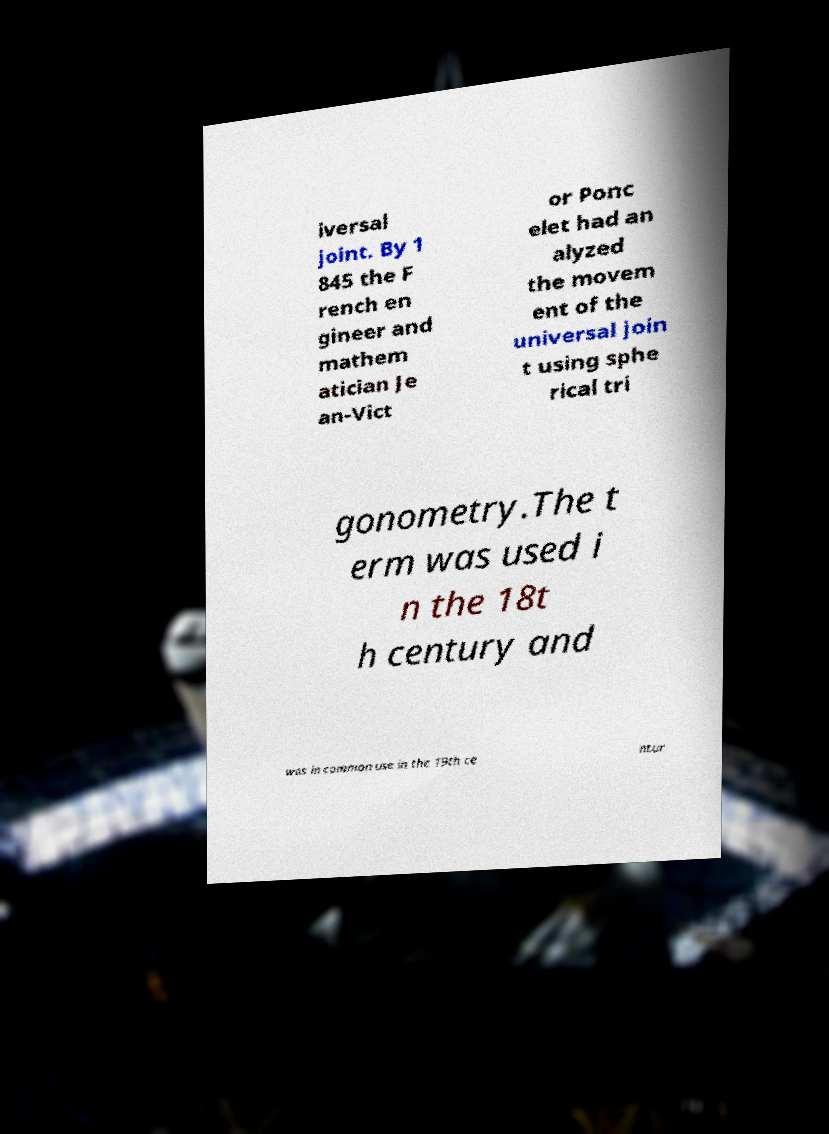I need the written content from this picture converted into text. Can you do that? iversal joint. By 1 845 the F rench en gineer and mathem atician Je an-Vict or Ponc elet had an alyzed the movem ent of the universal join t using sphe rical tri gonometry.The t erm was used i n the 18t h century and was in common use in the 19th ce ntur 